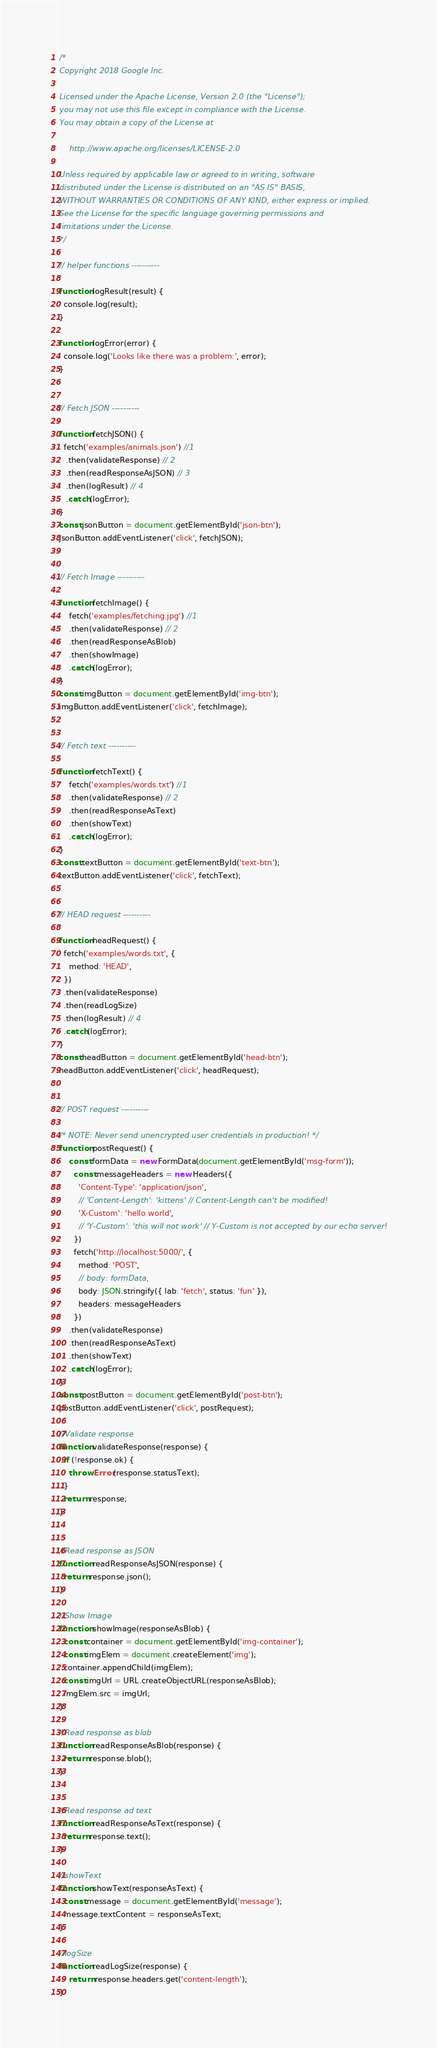<code> <loc_0><loc_0><loc_500><loc_500><_JavaScript_>/*
Copyright 2018 Google Inc.

Licensed under the Apache License, Version 2.0 (the "License");
you may not use this file except in compliance with the License.
You may obtain a copy of the License at

    http://www.apache.org/licenses/LICENSE-2.0

Unless required by applicable law or agreed to in writing, software
distributed under the License is distributed on an "AS IS" BASIS,
WITHOUT WARRANTIES OR CONDITIONS OF ANY KIND, either express or implied.
See the License for the specific language governing permissions and
limitations under the License.
*/

// helper functions ----------

function logResult(result) {
  console.log(result);
}

function logError(error) {
  console.log('Looks like there was a problem:', error);
}


// Fetch JSON ----------

function fetchJSON() {
  fetch('examples/animals.json') //1
   .then(validateResponse) // 2
   .then(readResponseAsJSON) // 3
   .then(logResult) // 4
   .catch(logError);
}
const jsonButton = document.getElementById('json-btn');
jsonButton.addEventListener('click', fetchJSON);


// Fetch Image ----------

function fetchImage() {
    fetch('examples/fetching.jpg') //1
    .then(validateResponse) // 2
    .then(readResponseAsBlob)
    .then(showImage)
    .catch(logError);
}
const imgButton = document.getElementById('img-btn');
imgButton.addEventListener('click', fetchImage);


// Fetch text ----------

function fetchText() {
    fetch('examples/words.txt') //1
    .then(validateResponse) // 2
    .then(readResponseAsText)
    .then(showText)
    .catch(logError);
}
const textButton = document.getElementById('text-btn');
textButton.addEventListener('click', fetchText);


// HEAD request ----------

function headRequest() {
  fetch('examples/words.txt', {
    method: 'HEAD',
  })
  .then(validateResponse)
  .then(readLogSize)
  .then(logResult) // 4
  .catch(logError);
}
const headButton = document.getElementById('head-btn');
headButton.addEventListener('click', headRequest);


// POST request ----------

/* NOTE: Never send unencrypted user credentials in production! */
function postRequest() {
	const formData = new FormData(document.getElementById('msg-form'));
	  const messageHeaders = new Headers({
	    'Content-Type': 'application/json',
	    // 'Content-Length': 'kittens' // Content-Length can't be modified!
	    'X-Custom': 'hello world',
	    // 'Y-Custom': 'this will not work' // Y-Custom is not accepted by our echo server!
	  })
	  fetch('http://localhost:5000/', {
	    method: 'POST',
	    // body: formData,
	    body: JSON.stringify({ lab: 'fetch', status: 'fun' }),
	    headers: messageHeaders
	  })
	.then(validateResponse)
    .then(readResponseAsText)
    .then(showText)
    .catch(logError);
}
const postButton = document.getElementById('post-btn');
postButton.addEventListener('click', postRequest);

//Validate response
function validateResponse(response) {
  if (!response.ok) {
    throw Error(response.statusText);
  }
  return response;
}


//Read response as JSON
function readResponseAsJSON(response) {
  return response.json();
}

//Show Image
function showImage(responseAsBlob) {
  const container = document.getElementById('img-container');
  const imgElem = document.createElement('img');
  container.appendChild(imgElem);
  const imgUrl = URL.createObjectURL(responseAsBlob);
  imgElem.src = imgUrl;
}

//Read response as blob
function readResponseAsBlob(response) {
  return response.blob();
}


//Read response ad text
function readResponseAsText(response) {
  return response.text();
}

//showText
function showText(responseAsText) {
  const message = document.getElementById('message');
  message.textContent = responseAsText;
}

//logSize
function readLogSize(response) {
	return response.headers.get('content-length');
}</code> 